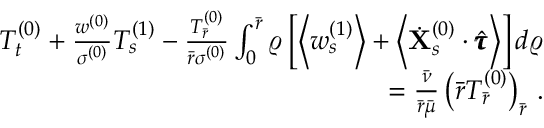Convert formula to latex. <formula><loc_0><loc_0><loc_500><loc_500>\begin{array} { r } { T _ { t } ^ { ( 0 ) } + \frac { w ^ { ( 0 ) } } { \sigma ^ { ( 0 ) } } T _ { s } ^ { ( 1 ) } - \frac { T _ { \bar { r } } ^ { ( 0 ) } } { \bar { r } \sigma ^ { ( 0 ) } } \int _ { 0 } ^ { \bar { r } } \varrho \left [ \left < w _ { s } ^ { ( 1 ) } \right > + \left < \dot { X } _ { s } ^ { ( 0 ) } \cdot \hat { \pm b { \tau } } \right > \right ] d \varrho } \\ { = \frac { \bar { \nu } } { \bar { r } \bar { \mu } } \left ( \bar { r } T _ { \bar { r } } ^ { ( 0 ) } \right ) _ { \bar { r } } \, . } \end{array}</formula> 